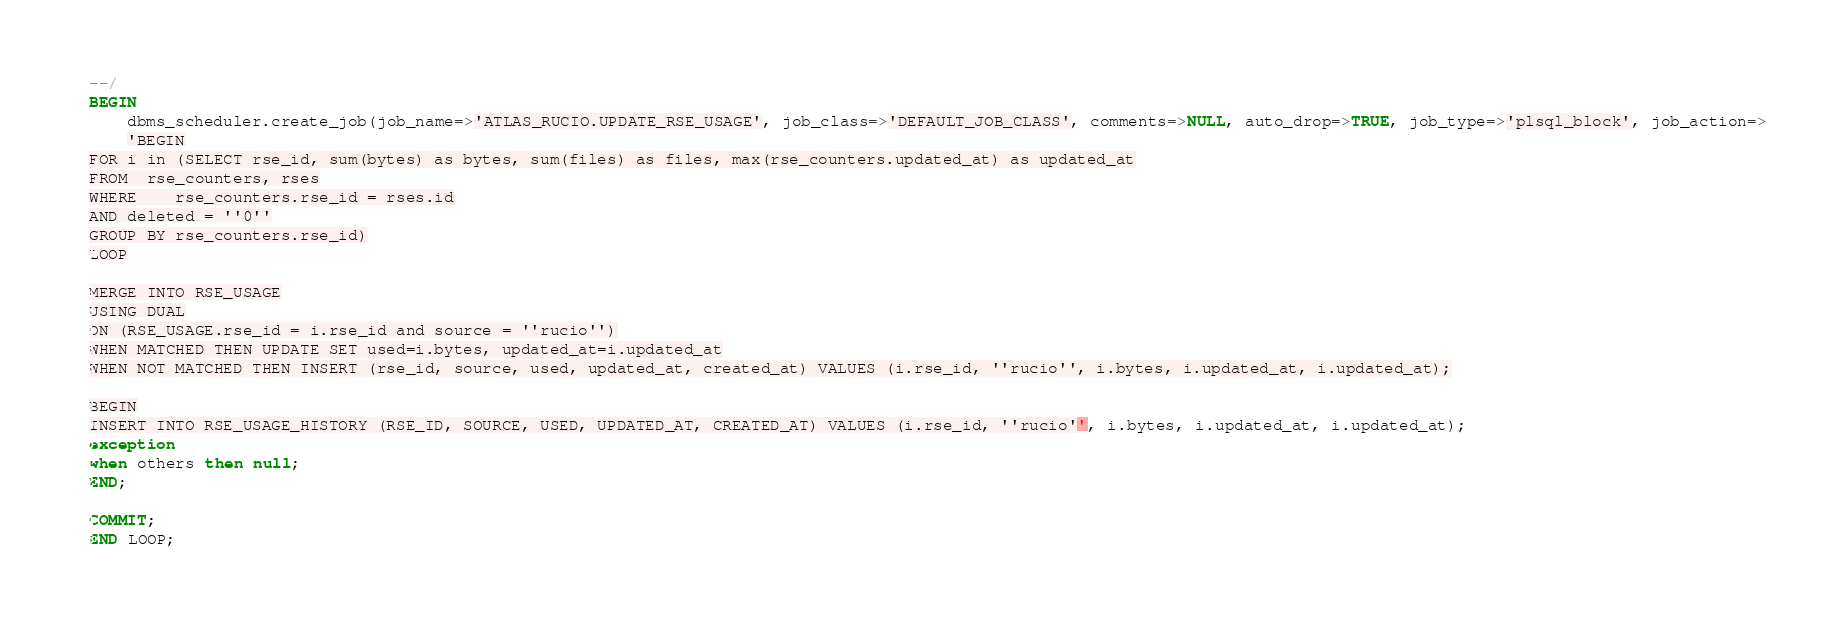Convert code to text. <code><loc_0><loc_0><loc_500><loc_500><_SQL_>--/
BEGIN
    dbms_scheduler.create_job(job_name=>'ATLAS_RUCIO.UPDATE_RSE_USAGE', job_class=>'DEFAULT_JOB_CLASS', comments=>NULL, auto_drop=>TRUE, job_type=>'plsql_block', job_action=>
    'BEGIN
FOR i in (SELECT rse_id, sum(bytes) as bytes, sum(files) as files, max(rse_counters.updated_at) as updated_at
FROM  rse_counters, rses
WHERE    rse_counters.rse_id = rses.id
AND deleted = ''0''
GROUP BY rse_counters.rse_id)
LOOP

MERGE INTO RSE_USAGE
USING DUAL
ON (RSE_USAGE.rse_id = i.rse_id and source = ''rucio'')
WHEN MATCHED THEN UPDATE SET used=i.bytes, updated_at=i.updated_at
WHEN NOT MATCHED THEN INSERT (rse_id, source, used, updated_at, created_at) VALUES (i.rse_id, ''rucio'', i.bytes, i.updated_at, i.updated_at);

BEGIN
INSERT INTO RSE_USAGE_HISTORY (RSE_ID, SOURCE, USED, UPDATED_AT, CREATED_AT) VALUES (i.rse_id, ''rucio'', i.bytes, i.updated_at, i.updated_at);
exception
when others then null;
END;

COMMIT;
END LOOP;</code> 